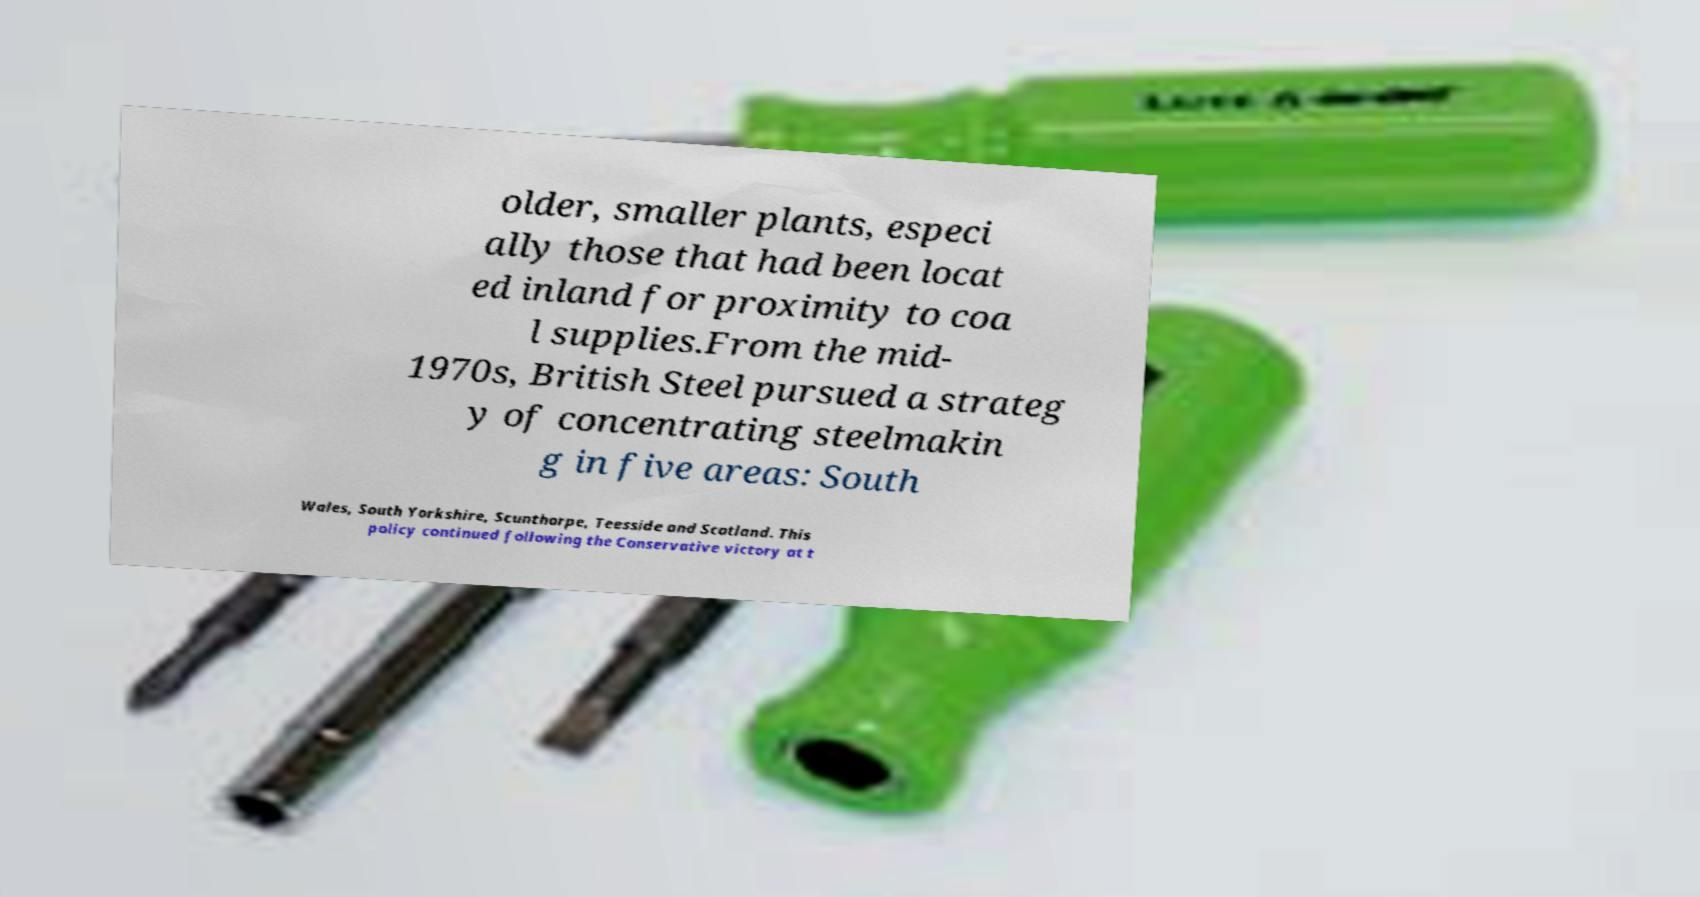Please read and relay the text visible in this image. What does it say? older, smaller plants, especi ally those that had been locat ed inland for proximity to coa l supplies.From the mid- 1970s, British Steel pursued a strateg y of concentrating steelmakin g in five areas: South Wales, South Yorkshire, Scunthorpe, Teesside and Scotland. This policy continued following the Conservative victory at t 